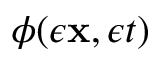Convert formula to latex. <formula><loc_0><loc_0><loc_500><loc_500>\phi ( \epsilon { x } , \epsilon t )</formula> 